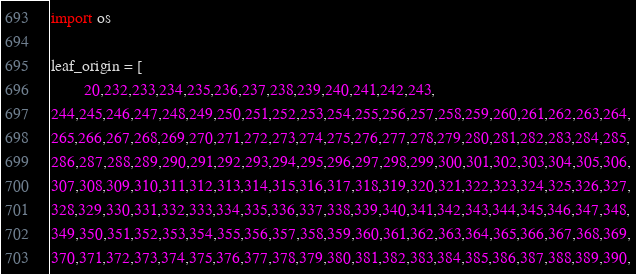Convert code to text. <code><loc_0><loc_0><loc_500><loc_500><_Python_>import os

leaf_origin = [
        20,232,233,234,235,236,237,238,239,240,241,242,243,
244,245,246,247,248,249,250,251,252,253,254,255,256,257,258,259,260,261,262,263,264,
265,266,267,268,269,270,271,272,273,274,275,276,277,278,279,280,281,282,283,284,285,
286,287,288,289,290,291,292,293,294,295,296,297,298,299,300,301,302,303,304,305,306,
307,308,309,310,311,312,313,314,315,316,317,318,319,320,321,322,323,324,325,326,327,
328,329,330,331,332,333,334,335,336,337,338,339,340,341,342,343,344,345,346,347,348,
349,350,351,352,353,354,355,356,357,358,359,360,361,362,363,364,365,366,367,368,369,
370,371,372,373,374,375,376,377,378,379,380,381,382,383,384,385,386,387,388,389,390,</code> 